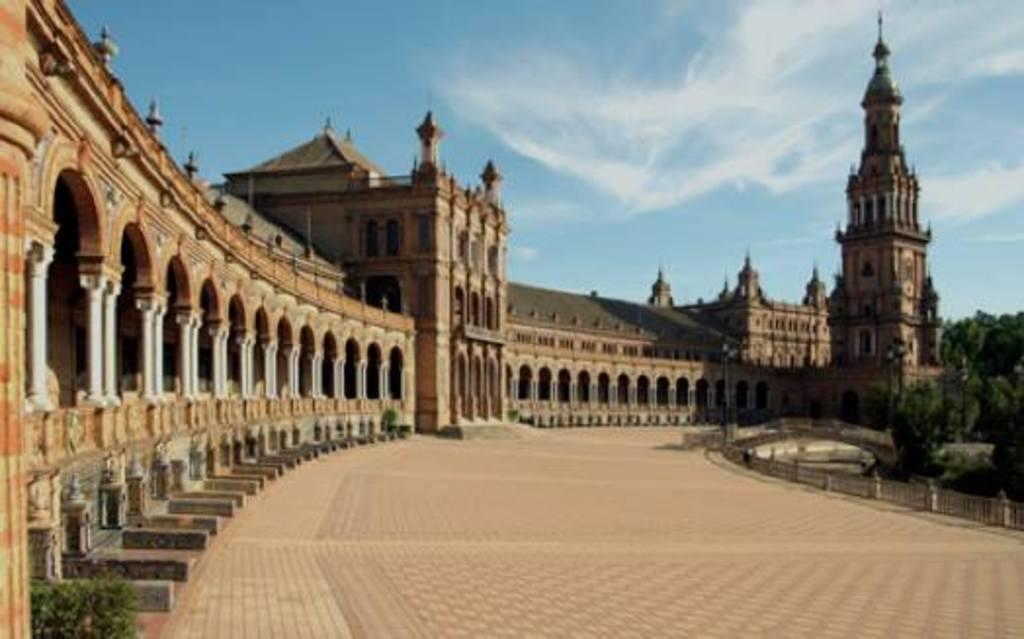What type of structure is present in the image? There is a building in the image. What part of the building can be seen in the image? There is a floor visible in the image. What type of natural element is present in the image? There are trees in the image. What type of powder is being used to clean the desk in the image? There is no desk or powder present in the image; it only features a building, a floor, and trees. 